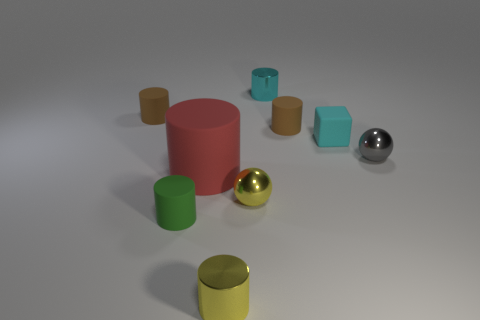Is the number of tiny rubber things that are on the left side of the tiny cyan cube less than the number of tiny yellow metallic things?
Keep it short and to the point. No. There is a green thing that is the same shape as the red rubber thing; what material is it?
Give a very brief answer. Rubber. The tiny matte object that is behind the cyan cube and on the right side of the big red matte thing has what shape?
Offer a very short reply. Cylinder. The tiny yellow thing that is made of the same material as the yellow ball is what shape?
Ensure brevity in your answer.  Cylinder. There is a sphere that is to the right of the cyan rubber cube; what is its material?
Offer a very short reply. Metal. There is a brown object that is right of the green object; does it have the same size as the ball behind the big thing?
Offer a very short reply. Yes. The big matte cylinder has what color?
Give a very brief answer. Red. Do the shiny object that is right of the small cyan cylinder and the big red thing have the same shape?
Provide a short and direct response. No. What material is the big red thing?
Give a very brief answer. Rubber. What is the shape of the green rubber object that is the same size as the gray metal object?
Your answer should be very brief. Cylinder. 